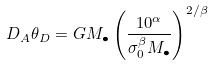<formula> <loc_0><loc_0><loc_500><loc_500>D _ { A } \theta _ { D } = G M _ { \bullet } \left ( \frac { 1 0 ^ { \alpha } } { \sigma _ { 0 } ^ { \beta } M _ { \bullet } } \right ) ^ { 2 / \beta }</formula> 